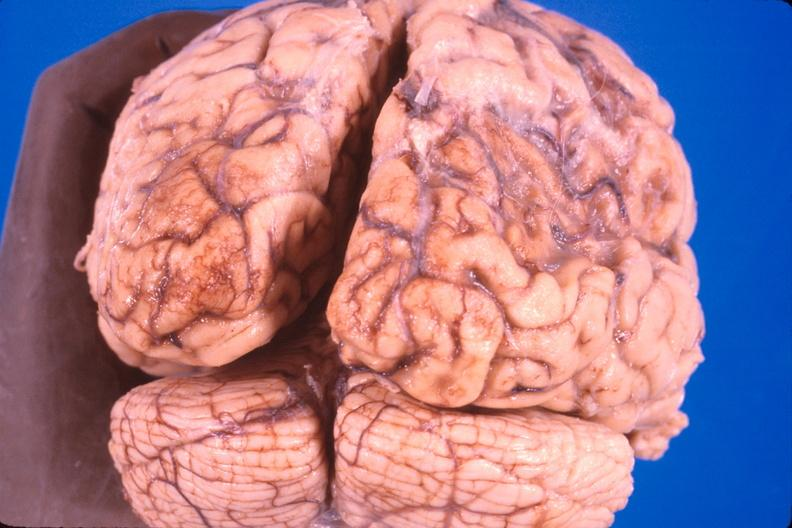does chloramphenicol toxicity show brain, old infarcts, embolic?
Answer the question using a single word or phrase. No 